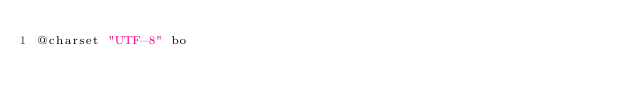<code> <loc_0><loc_0><loc_500><loc_500><_CSS_>@charset "UTF-8" bo</code> 